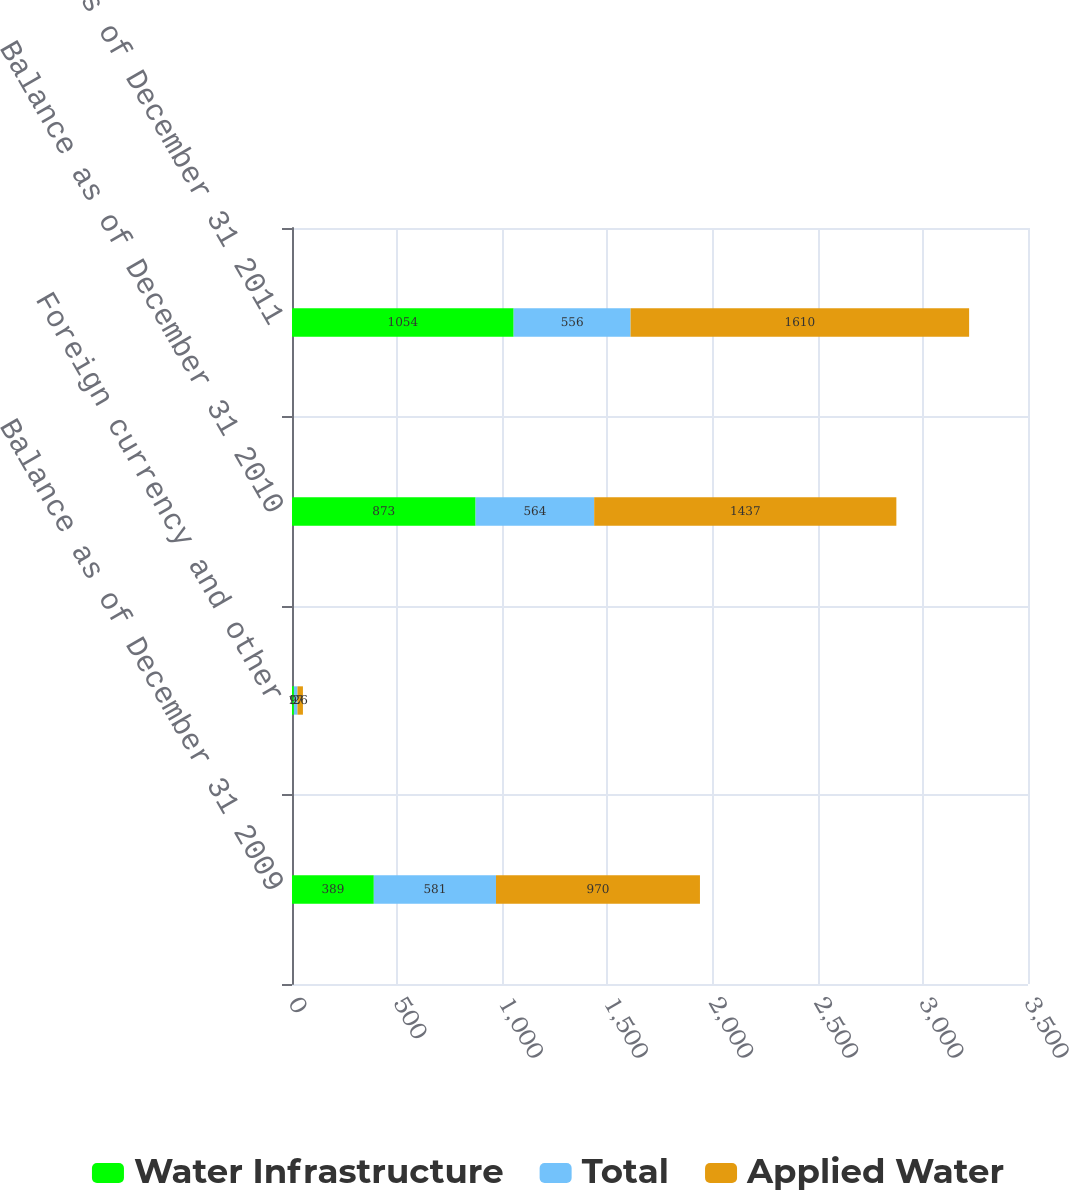Convert chart to OTSL. <chart><loc_0><loc_0><loc_500><loc_500><stacked_bar_chart><ecel><fcel>Balance as of December 31 2009<fcel>Foreign currency and other<fcel>Balance as of December 31 2010<fcel>Balance as of December 31 2011<nl><fcel>Water Infrastructure<fcel>389<fcel>9<fcel>873<fcel>1054<nl><fcel>Total<fcel>581<fcel>17<fcel>564<fcel>556<nl><fcel>Applied Water<fcel>970<fcel>26<fcel>1437<fcel>1610<nl></chart> 